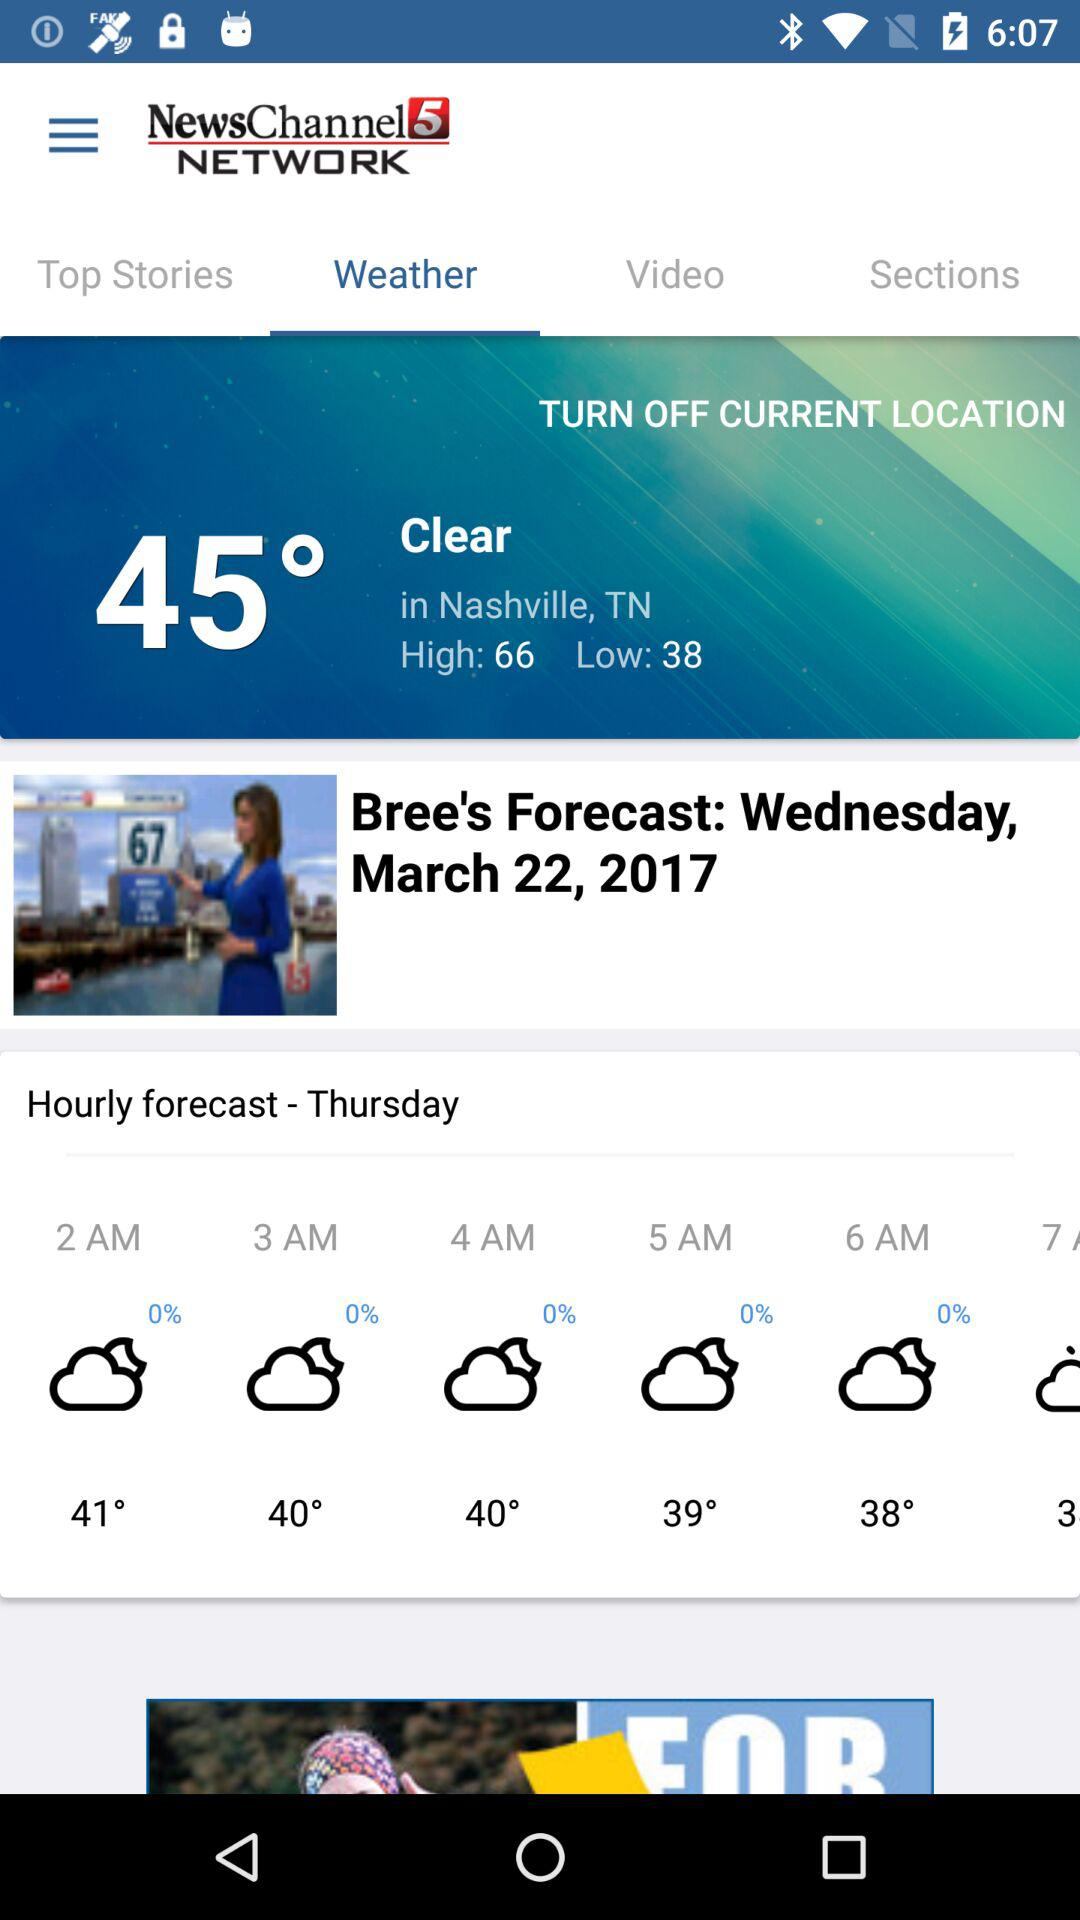What is the temperature going to be on Friday?
When the provided information is insufficient, respond with <no answer>. <no answer> 